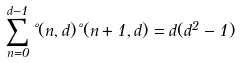<formula> <loc_0><loc_0><loc_500><loc_500>\sum _ { n = 0 } ^ { d - 1 } \nu ( n , d ) \nu ( n + 1 , d ) = d ( d ^ { 2 } - 1 )</formula> 